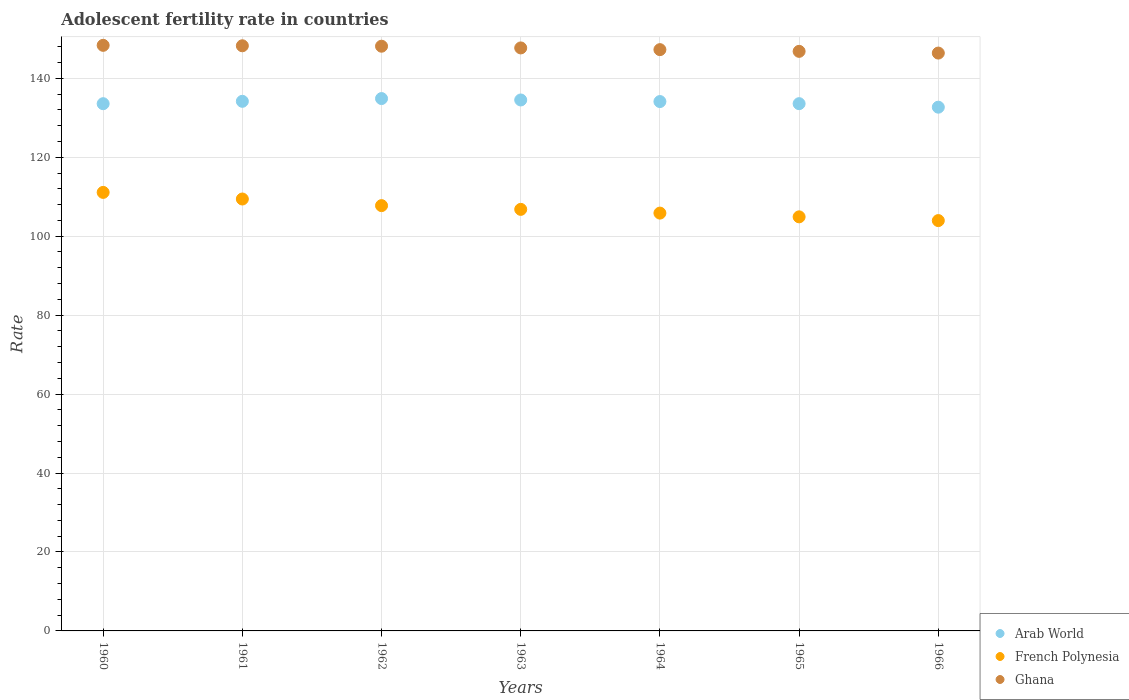What is the adolescent fertility rate in Arab World in 1962?
Provide a short and direct response. 134.86. Across all years, what is the maximum adolescent fertility rate in Ghana?
Provide a short and direct response. 148.34. Across all years, what is the minimum adolescent fertility rate in Arab World?
Give a very brief answer. 132.68. In which year was the adolescent fertility rate in French Polynesia maximum?
Your answer should be compact. 1960. In which year was the adolescent fertility rate in Arab World minimum?
Keep it short and to the point. 1966. What is the total adolescent fertility rate in Ghana in the graph?
Your answer should be very brief. 1032.86. What is the difference between the adolescent fertility rate in Arab World in 1960 and that in 1966?
Provide a short and direct response. 0.88. What is the difference between the adolescent fertility rate in Arab World in 1960 and the adolescent fertility rate in French Polynesia in 1965?
Provide a succinct answer. 28.66. What is the average adolescent fertility rate in French Polynesia per year?
Ensure brevity in your answer.  107.1. In the year 1964, what is the difference between the adolescent fertility rate in Ghana and adolescent fertility rate in Arab World?
Make the answer very short. 13.15. In how many years, is the adolescent fertility rate in Ghana greater than 100?
Ensure brevity in your answer.  7. What is the ratio of the adolescent fertility rate in Arab World in 1961 to that in 1966?
Provide a short and direct response. 1.01. Is the difference between the adolescent fertility rate in Ghana in 1963 and 1966 greater than the difference between the adolescent fertility rate in Arab World in 1963 and 1966?
Offer a terse response. No. What is the difference between the highest and the second highest adolescent fertility rate in Arab World?
Keep it short and to the point. 0.36. What is the difference between the highest and the lowest adolescent fertility rate in Arab World?
Provide a short and direct response. 2.18. In how many years, is the adolescent fertility rate in Arab World greater than the average adolescent fertility rate in Arab World taken over all years?
Provide a short and direct response. 4. Is the sum of the adolescent fertility rate in Arab World in 1960 and 1963 greater than the maximum adolescent fertility rate in French Polynesia across all years?
Your answer should be compact. Yes. Is it the case that in every year, the sum of the adolescent fertility rate in Ghana and adolescent fertility rate in French Polynesia  is greater than the adolescent fertility rate in Arab World?
Keep it short and to the point. Yes. Does the adolescent fertility rate in Ghana monotonically increase over the years?
Your answer should be very brief. No. Where does the legend appear in the graph?
Your answer should be compact. Bottom right. How many legend labels are there?
Provide a succinct answer. 3. What is the title of the graph?
Ensure brevity in your answer.  Adolescent fertility rate in countries. What is the label or title of the Y-axis?
Give a very brief answer. Rate. What is the Rate of Arab World in 1960?
Ensure brevity in your answer.  133.56. What is the Rate of French Polynesia in 1960?
Keep it short and to the point. 111.09. What is the Rate of Ghana in 1960?
Offer a terse response. 148.34. What is the Rate of Arab World in 1961?
Give a very brief answer. 134.16. What is the Rate of French Polynesia in 1961?
Ensure brevity in your answer.  109.41. What is the Rate in Ghana in 1961?
Provide a succinct answer. 148.23. What is the Rate in Arab World in 1962?
Provide a short and direct response. 134.86. What is the Rate of French Polynesia in 1962?
Offer a terse response. 107.74. What is the Rate in Ghana in 1962?
Offer a terse response. 148.12. What is the Rate of Arab World in 1963?
Ensure brevity in your answer.  134.5. What is the Rate in French Polynesia in 1963?
Provide a succinct answer. 106.79. What is the Rate in Ghana in 1963?
Your response must be concise. 147.69. What is the Rate in Arab World in 1964?
Make the answer very short. 134.1. What is the Rate in French Polynesia in 1964?
Offer a very short reply. 105.84. What is the Rate in Ghana in 1964?
Your response must be concise. 147.26. What is the Rate in Arab World in 1965?
Offer a very short reply. 133.57. What is the Rate of French Polynesia in 1965?
Offer a terse response. 104.9. What is the Rate of Ghana in 1965?
Offer a terse response. 146.82. What is the Rate in Arab World in 1966?
Give a very brief answer. 132.68. What is the Rate in French Polynesia in 1966?
Provide a succinct answer. 103.95. What is the Rate of Ghana in 1966?
Ensure brevity in your answer.  146.39. Across all years, what is the maximum Rate in Arab World?
Your answer should be very brief. 134.86. Across all years, what is the maximum Rate of French Polynesia?
Keep it short and to the point. 111.09. Across all years, what is the maximum Rate in Ghana?
Keep it short and to the point. 148.34. Across all years, what is the minimum Rate of Arab World?
Your answer should be compact. 132.68. Across all years, what is the minimum Rate of French Polynesia?
Provide a short and direct response. 103.95. Across all years, what is the minimum Rate of Ghana?
Your answer should be very brief. 146.39. What is the total Rate of Arab World in the graph?
Make the answer very short. 937.44. What is the total Rate in French Polynesia in the graph?
Provide a succinct answer. 749.73. What is the total Rate in Ghana in the graph?
Your answer should be very brief. 1032.86. What is the difference between the Rate of Arab World in 1960 and that in 1961?
Keep it short and to the point. -0.6. What is the difference between the Rate of French Polynesia in 1960 and that in 1961?
Ensure brevity in your answer.  1.68. What is the difference between the Rate in Ghana in 1960 and that in 1961?
Your answer should be compact. 0.11. What is the difference between the Rate of Arab World in 1960 and that in 1962?
Ensure brevity in your answer.  -1.3. What is the difference between the Rate of French Polynesia in 1960 and that in 1962?
Give a very brief answer. 3.35. What is the difference between the Rate of Ghana in 1960 and that in 1962?
Offer a very short reply. 0.22. What is the difference between the Rate in Arab World in 1960 and that in 1963?
Your answer should be compact. -0.94. What is the difference between the Rate of French Polynesia in 1960 and that in 1963?
Provide a short and direct response. 4.3. What is the difference between the Rate of Ghana in 1960 and that in 1963?
Give a very brief answer. 0.66. What is the difference between the Rate of Arab World in 1960 and that in 1964?
Provide a succinct answer. -0.54. What is the difference between the Rate of French Polynesia in 1960 and that in 1964?
Keep it short and to the point. 5.25. What is the difference between the Rate in Ghana in 1960 and that in 1964?
Your answer should be very brief. 1.09. What is the difference between the Rate in Arab World in 1960 and that in 1965?
Your response must be concise. -0.01. What is the difference between the Rate in French Polynesia in 1960 and that in 1965?
Your response must be concise. 6.19. What is the difference between the Rate of Ghana in 1960 and that in 1965?
Your response must be concise. 1.52. What is the difference between the Rate in Arab World in 1960 and that in 1966?
Provide a succinct answer. 0.88. What is the difference between the Rate in French Polynesia in 1960 and that in 1966?
Ensure brevity in your answer.  7.14. What is the difference between the Rate in Ghana in 1960 and that in 1966?
Give a very brief answer. 1.96. What is the difference between the Rate in Arab World in 1961 and that in 1962?
Offer a terse response. -0.7. What is the difference between the Rate in French Polynesia in 1961 and that in 1962?
Offer a terse response. 1.68. What is the difference between the Rate of Ghana in 1961 and that in 1962?
Offer a very short reply. 0.11. What is the difference between the Rate in Arab World in 1961 and that in 1963?
Your answer should be very brief. -0.34. What is the difference between the Rate in French Polynesia in 1961 and that in 1963?
Your answer should be compact. 2.62. What is the difference between the Rate of Ghana in 1961 and that in 1963?
Your answer should be very brief. 0.54. What is the difference between the Rate of Arab World in 1961 and that in 1964?
Ensure brevity in your answer.  0.06. What is the difference between the Rate of French Polynesia in 1961 and that in 1964?
Keep it short and to the point. 3.57. What is the difference between the Rate of Ghana in 1961 and that in 1964?
Keep it short and to the point. 0.98. What is the difference between the Rate in Arab World in 1961 and that in 1965?
Provide a succinct answer. 0.6. What is the difference between the Rate of French Polynesia in 1961 and that in 1965?
Provide a succinct answer. 4.52. What is the difference between the Rate in Ghana in 1961 and that in 1965?
Your response must be concise. 1.41. What is the difference between the Rate in Arab World in 1961 and that in 1966?
Provide a succinct answer. 1.49. What is the difference between the Rate of French Polynesia in 1961 and that in 1966?
Keep it short and to the point. 5.47. What is the difference between the Rate of Ghana in 1961 and that in 1966?
Provide a short and direct response. 1.85. What is the difference between the Rate of Arab World in 1962 and that in 1963?
Offer a very short reply. 0.36. What is the difference between the Rate of French Polynesia in 1962 and that in 1963?
Offer a very short reply. 0.95. What is the difference between the Rate in Ghana in 1962 and that in 1963?
Your response must be concise. 0.43. What is the difference between the Rate in Arab World in 1962 and that in 1964?
Give a very brief answer. 0.76. What is the difference between the Rate of French Polynesia in 1962 and that in 1964?
Give a very brief answer. 1.89. What is the difference between the Rate of Ghana in 1962 and that in 1964?
Your answer should be compact. 0.87. What is the difference between the Rate in Arab World in 1962 and that in 1965?
Ensure brevity in your answer.  1.29. What is the difference between the Rate in French Polynesia in 1962 and that in 1965?
Ensure brevity in your answer.  2.84. What is the difference between the Rate of Ghana in 1962 and that in 1965?
Provide a succinct answer. 1.3. What is the difference between the Rate in Arab World in 1962 and that in 1966?
Ensure brevity in your answer.  2.18. What is the difference between the Rate in French Polynesia in 1962 and that in 1966?
Your answer should be compact. 3.79. What is the difference between the Rate in Ghana in 1962 and that in 1966?
Provide a succinct answer. 1.74. What is the difference between the Rate of Arab World in 1963 and that in 1964?
Keep it short and to the point. 0.4. What is the difference between the Rate of Ghana in 1963 and that in 1964?
Provide a short and direct response. 0.43. What is the difference between the Rate in Arab World in 1963 and that in 1965?
Ensure brevity in your answer.  0.94. What is the difference between the Rate of French Polynesia in 1963 and that in 1965?
Provide a short and direct response. 1.89. What is the difference between the Rate of Ghana in 1963 and that in 1965?
Your response must be concise. 0.87. What is the difference between the Rate in Arab World in 1963 and that in 1966?
Your response must be concise. 1.83. What is the difference between the Rate in French Polynesia in 1963 and that in 1966?
Give a very brief answer. 2.84. What is the difference between the Rate of Ghana in 1963 and that in 1966?
Offer a very short reply. 1.3. What is the difference between the Rate of Arab World in 1964 and that in 1965?
Keep it short and to the point. 0.54. What is the difference between the Rate in French Polynesia in 1964 and that in 1965?
Your answer should be very brief. 0.95. What is the difference between the Rate in Ghana in 1964 and that in 1965?
Your answer should be very brief. 0.43. What is the difference between the Rate in Arab World in 1964 and that in 1966?
Offer a terse response. 1.43. What is the difference between the Rate in French Polynesia in 1964 and that in 1966?
Your answer should be very brief. 1.89. What is the difference between the Rate in Ghana in 1964 and that in 1966?
Provide a short and direct response. 0.87. What is the difference between the Rate in Arab World in 1965 and that in 1966?
Offer a terse response. 0.89. What is the difference between the Rate of French Polynesia in 1965 and that in 1966?
Offer a terse response. 0.95. What is the difference between the Rate of Ghana in 1965 and that in 1966?
Offer a terse response. 0.43. What is the difference between the Rate of Arab World in 1960 and the Rate of French Polynesia in 1961?
Your answer should be very brief. 24.15. What is the difference between the Rate of Arab World in 1960 and the Rate of Ghana in 1961?
Your answer should be compact. -14.67. What is the difference between the Rate of French Polynesia in 1960 and the Rate of Ghana in 1961?
Provide a short and direct response. -37.14. What is the difference between the Rate of Arab World in 1960 and the Rate of French Polynesia in 1962?
Your response must be concise. 25.82. What is the difference between the Rate of Arab World in 1960 and the Rate of Ghana in 1962?
Your answer should be compact. -14.56. What is the difference between the Rate of French Polynesia in 1960 and the Rate of Ghana in 1962?
Ensure brevity in your answer.  -37.03. What is the difference between the Rate of Arab World in 1960 and the Rate of French Polynesia in 1963?
Make the answer very short. 26.77. What is the difference between the Rate in Arab World in 1960 and the Rate in Ghana in 1963?
Your answer should be compact. -14.13. What is the difference between the Rate in French Polynesia in 1960 and the Rate in Ghana in 1963?
Your answer should be compact. -36.6. What is the difference between the Rate of Arab World in 1960 and the Rate of French Polynesia in 1964?
Your answer should be compact. 27.72. What is the difference between the Rate in Arab World in 1960 and the Rate in Ghana in 1964?
Give a very brief answer. -13.69. What is the difference between the Rate of French Polynesia in 1960 and the Rate of Ghana in 1964?
Your answer should be very brief. -36.16. What is the difference between the Rate in Arab World in 1960 and the Rate in French Polynesia in 1965?
Offer a very short reply. 28.66. What is the difference between the Rate in Arab World in 1960 and the Rate in Ghana in 1965?
Your response must be concise. -13.26. What is the difference between the Rate in French Polynesia in 1960 and the Rate in Ghana in 1965?
Provide a short and direct response. -35.73. What is the difference between the Rate of Arab World in 1960 and the Rate of French Polynesia in 1966?
Make the answer very short. 29.61. What is the difference between the Rate of Arab World in 1960 and the Rate of Ghana in 1966?
Keep it short and to the point. -12.83. What is the difference between the Rate of French Polynesia in 1960 and the Rate of Ghana in 1966?
Provide a short and direct response. -35.3. What is the difference between the Rate of Arab World in 1961 and the Rate of French Polynesia in 1962?
Offer a very short reply. 26.43. What is the difference between the Rate in Arab World in 1961 and the Rate in Ghana in 1962?
Offer a terse response. -13.96. What is the difference between the Rate in French Polynesia in 1961 and the Rate in Ghana in 1962?
Give a very brief answer. -38.71. What is the difference between the Rate in Arab World in 1961 and the Rate in French Polynesia in 1963?
Keep it short and to the point. 27.37. What is the difference between the Rate in Arab World in 1961 and the Rate in Ghana in 1963?
Your answer should be compact. -13.53. What is the difference between the Rate in French Polynesia in 1961 and the Rate in Ghana in 1963?
Offer a terse response. -38.27. What is the difference between the Rate of Arab World in 1961 and the Rate of French Polynesia in 1964?
Offer a very short reply. 28.32. What is the difference between the Rate of Arab World in 1961 and the Rate of Ghana in 1964?
Offer a terse response. -13.09. What is the difference between the Rate in French Polynesia in 1961 and the Rate in Ghana in 1964?
Ensure brevity in your answer.  -37.84. What is the difference between the Rate in Arab World in 1961 and the Rate in French Polynesia in 1965?
Provide a succinct answer. 29.27. What is the difference between the Rate of Arab World in 1961 and the Rate of Ghana in 1965?
Provide a succinct answer. -12.66. What is the difference between the Rate of French Polynesia in 1961 and the Rate of Ghana in 1965?
Your answer should be compact. -37.41. What is the difference between the Rate in Arab World in 1961 and the Rate in French Polynesia in 1966?
Keep it short and to the point. 30.21. What is the difference between the Rate in Arab World in 1961 and the Rate in Ghana in 1966?
Provide a succinct answer. -12.22. What is the difference between the Rate in French Polynesia in 1961 and the Rate in Ghana in 1966?
Offer a very short reply. -36.97. What is the difference between the Rate of Arab World in 1962 and the Rate of French Polynesia in 1963?
Make the answer very short. 28.07. What is the difference between the Rate of Arab World in 1962 and the Rate of Ghana in 1963?
Offer a very short reply. -12.83. What is the difference between the Rate in French Polynesia in 1962 and the Rate in Ghana in 1963?
Your response must be concise. -39.95. What is the difference between the Rate of Arab World in 1962 and the Rate of French Polynesia in 1964?
Offer a very short reply. 29.02. What is the difference between the Rate of Arab World in 1962 and the Rate of Ghana in 1964?
Your answer should be very brief. -12.39. What is the difference between the Rate in French Polynesia in 1962 and the Rate in Ghana in 1964?
Give a very brief answer. -39.52. What is the difference between the Rate of Arab World in 1962 and the Rate of French Polynesia in 1965?
Offer a very short reply. 29.96. What is the difference between the Rate of Arab World in 1962 and the Rate of Ghana in 1965?
Make the answer very short. -11.96. What is the difference between the Rate of French Polynesia in 1962 and the Rate of Ghana in 1965?
Provide a succinct answer. -39.08. What is the difference between the Rate of Arab World in 1962 and the Rate of French Polynesia in 1966?
Provide a succinct answer. 30.91. What is the difference between the Rate in Arab World in 1962 and the Rate in Ghana in 1966?
Offer a terse response. -11.53. What is the difference between the Rate in French Polynesia in 1962 and the Rate in Ghana in 1966?
Your answer should be compact. -38.65. What is the difference between the Rate of Arab World in 1963 and the Rate of French Polynesia in 1964?
Provide a short and direct response. 28.66. What is the difference between the Rate of Arab World in 1963 and the Rate of Ghana in 1964?
Offer a terse response. -12.75. What is the difference between the Rate of French Polynesia in 1963 and the Rate of Ghana in 1964?
Offer a very short reply. -40.46. What is the difference between the Rate in Arab World in 1963 and the Rate in French Polynesia in 1965?
Keep it short and to the point. 29.61. What is the difference between the Rate of Arab World in 1963 and the Rate of Ghana in 1965?
Your answer should be compact. -12.32. What is the difference between the Rate of French Polynesia in 1963 and the Rate of Ghana in 1965?
Your answer should be very brief. -40.03. What is the difference between the Rate in Arab World in 1963 and the Rate in French Polynesia in 1966?
Provide a short and direct response. 30.56. What is the difference between the Rate in Arab World in 1963 and the Rate in Ghana in 1966?
Give a very brief answer. -11.88. What is the difference between the Rate in French Polynesia in 1963 and the Rate in Ghana in 1966?
Keep it short and to the point. -39.59. What is the difference between the Rate of Arab World in 1964 and the Rate of French Polynesia in 1965?
Offer a terse response. 29.21. What is the difference between the Rate in Arab World in 1964 and the Rate in Ghana in 1965?
Give a very brief answer. -12.72. What is the difference between the Rate of French Polynesia in 1964 and the Rate of Ghana in 1965?
Offer a very short reply. -40.98. What is the difference between the Rate in Arab World in 1964 and the Rate in French Polynesia in 1966?
Give a very brief answer. 30.15. What is the difference between the Rate in Arab World in 1964 and the Rate in Ghana in 1966?
Offer a terse response. -12.28. What is the difference between the Rate in French Polynesia in 1964 and the Rate in Ghana in 1966?
Ensure brevity in your answer.  -40.54. What is the difference between the Rate in Arab World in 1965 and the Rate in French Polynesia in 1966?
Your answer should be compact. 29.62. What is the difference between the Rate of Arab World in 1965 and the Rate of Ghana in 1966?
Your answer should be very brief. -12.82. What is the difference between the Rate in French Polynesia in 1965 and the Rate in Ghana in 1966?
Make the answer very short. -41.49. What is the average Rate of Arab World per year?
Keep it short and to the point. 133.92. What is the average Rate in French Polynesia per year?
Your response must be concise. 107.1. What is the average Rate of Ghana per year?
Ensure brevity in your answer.  147.55. In the year 1960, what is the difference between the Rate of Arab World and Rate of French Polynesia?
Your answer should be very brief. 22.47. In the year 1960, what is the difference between the Rate in Arab World and Rate in Ghana?
Ensure brevity in your answer.  -14.78. In the year 1960, what is the difference between the Rate of French Polynesia and Rate of Ghana?
Ensure brevity in your answer.  -37.25. In the year 1961, what is the difference between the Rate of Arab World and Rate of French Polynesia?
Your answer should be compact. 24.75. In the year 1961, what is the difference between the Rate in Arab World and Rate in Ghana?
Make the answer very short. -14.07. In the year 1961, what is the difference between the Rate of French Polynesia and Rate of Ghana?
Make the answer very short. -38.82. In the year 1962, what is the difference between the Rate of Arab World and Rate of French Polynesia?
Ensure brevity in your answer.  27.12. In the year 1962, what is the difference between the Rate of Arab World and Rate of Ghana?
Offer a terse response. -13.26. In the year 1962, what is the difference between the Rate in French Polynesia and Rate in Ghana?
Offer a very short reply. -40.38. In the year 1963, what is the difference between the Rate in Arab World and Rate in French Polynesia?
Provide a succinct answer. 27.71. In the year 1963, what is the difference between the Rate in Arab World and Rate in Ghana?
Offer a terse response. -13.18. In the year 1963, what is the difference between the Rate of French Polynesia and Rate of Ghana?
Make the answer very short. -40.9. In the year 1964, what is the difference between the Rate in Arab World and Rate in French Polynesia?
Offer a terse response. 28.26. In the year 1964, what is the difference between the Rate of Arab World and Rate of Ghana?
Offer a terse response. -13.15. In the year 1964, what is the difference between the Rate in French Polynesia and Rate in Ghana?
Make the answer very short. -41.41. In the year 1965, what is the difference between the Rate of Arab World and Rate of French Polynesia?
Keep it short and to the point. 28.67. In the year 1965, what is the difference between the Rate in Arab World and Rate in Ghana?
Keep it short and to the point. -13.25. In the year 1965, what is the difference between the Rate of French Polynesia and Rate of Ghana?
Provide a short and direct response. -41.92. In the year 1966, what is the difference between the Rate in Arab World and Rate in French Polynesia?
Provide a short and direct response. 28.73. In the year 1966, what is the difference between the Rate in Arab World and Rate in Ghana?
Keep it short and to the point. -13.71. In the year 1966, what is the difference between the Rate of French Polynesia and Rate of Ghana?
Provide a short and direct response. -42.44. What is the ratio of the Rate in French Polynesia in 1960 to that in 1961?
Offer a terse response. 1.02. What is the ratio of the Rate of Ghana in 1960 to that in 1961?
Your response must be concise. 1. What is the ratio of the Rate in Arab World in 1960 to that in 1962?
Your response must be concise. 0.99. What is the ratio of the Rate in French Polynesia in 1960 to that in 1962?
Give a very brief answer. 1.03. What is the ratio of the Rate of French Polynesia in 1960 to that in 1963?
Give a very brief answer. 1.04. What is the ratio of the Rate of Arab World in 1960 to that in 1964?
Make the answer very short. 1. What is the ratio of the Rate of French Polynesia in 1960 to that in 1964?
Your answer should be compact. 1.05. What is the ratio of the Rate of Ghana in 1960 to that in 1964?
Offer a very short reply. 1.01. What is the ratio of the Rate of Arab World in 1960 to that in 1965?
Give a very brief answer. 1. What is the ratio of the Rate of French Polynesia in 1960 to that in 1965?
Ensure brevity in your answer.  1.06. What is the ratio of the Rate of Ghana in 1960 to that in 1965?
Offer a very short reply. 1.01. What is the ratio of the Rate in French Polynesia in 1960 to that in 1966?
Offer a very short reply. 1.07. What is the ratio of the Rate of Ghana in 1960 to that in 1966?
Your answer should be compact. 1.01. What is the ratio of the Rate of Arab World in 1961 to that in 1962?
Provide a succinct answer. 0.99. What is the ratio of the Rate in French Polynesia in 1961 to that in 1962?
Keep it short and to the point. 1.02. What is the ratio of the Rate in Ghana in 1961 to that in 1962?
Provide a short and direct response. 1. What is the ratio of the Rate in French Polynesia in 1961 to that in 1963?
Provide a short and direct response. 1.02. What is the ratio of the Rate of Ghana in 1961 to that in 1963?
Your answer should be compact. 1. What is the ratio of the Rate in Arab World in 1961 to that in 1964?
Offer a very short reply. 1. What is the ratio of the Rate of French Polynesia in 1961 to that in 1964?
Keep it short and to the point. 1.03. What is the ratio of the Rate in Ghana in 1961 to that in 1964?
Offer a very short reply. 1.01. What is the ratio of the Rate in French Polynesia in 1961 to that in 1965?
Your answer should be compact. 1.04. What is the ratio of the Rate in Ghana in 1961 to that in 1965?
Keep it short and to the point. 1.01. What is the ratio of the Rate in Arab World in 1961 to that in 1966?
Your response must be concise. 1.01. What is the ratio of the Rate of French Polynesia in 1961 to that in 1966?
Provide a succinct answer. 1.05. What is the ratio of the Rate of Ghana in 1961 to that in 1966?
Make the answer very short. 1.01. What is the ratio of the Rate in French Polynesia in 1962 to that in 1963?
Your response must be concise. 1.01. What is the ratio of the Rate in Ghana in 1962 to that in 1963?
Your response must be concise. 1. What is the ratio of the Rate in Arab World in 1962 to that in 1964?
Your answer should be compact. 1.01. What is the ratio of the Rate in French Polynesia in 1962 to that in 1964?
Offer a very short reply. 1.02. What is the ratio of the Rate of Ghana in 1962 to that in 1964?
Give a very brief answer. 1.01. What is the ratio of the Rate of Arab World in 1962 to that in 1965?
Your response must be concise. 1.01. What is the ratio of the Rate of French Polynesia in 1962 to that in 1965?
Give a very brief answer. 1.03. What is the ratio of the Rate in Ghana in 1962 to that in 1965?
Provide a succinct answer. 1.01. What is the ratio of the Rate of Arab World in 1962 to that in 1966?
Offer a very short reply. 1.02. What is the ratio of the Rate of French Polynesia in 1962 to that in 1966?
Give a very brief answer. 1.04. What is the ratio of the Rate of Ghana in 1962 to that in 1966?
Your response must be concise. 1.01. What is the ratio of the Rate in Arab World in 1963 to that in 1964?
Provide a succinct answer. 1. What is the ratio of the Rate of French Polynesia in 1963 to that in 1965?
Provide a short and direct response. 1.02. What is the ratio of the Rate in Ghana in 1963 to that in 1965?
Provide a short and direct response. 1.01. What is the ratio of the Rate of Arab World in 1963 to that in 1966?
Your answer should be compact. 1.01. What is the ratio of the Rate in French Polynesia in 1963 to that in 1966?
Make the answer very short. 1.03. What is the ratio of the Rate in Ghana in 1963 to that in 1966?
Offer a very short reply. 1.01. What is the ratio of the Rate of Arab World in 1964 to that in 1965?
Give a very brief answer. 1. What is the ratio of the Rate of French Polynesia in 1964 to that in 1965?
Your answer should be compact. 1.01. What is the ratio of the Rate of Arab World in 1964 to that in 1966?
Ensure brevity in your answer.  1.01. What is the ratio of the Rate of French Polynesia in 1964 to that in 1966?
Your answer should be compact. 1.02. What is the ratio of the Rate in Ghana in 1964 to that in 1966?
Your response must be concise. 1.01. What is the ratio of the Rate of Arab World in 1965 to that in 1966?
Your answer should be compact. 1.01. What is the ratio of the Rate in French Polynesia in 1965 to that in 1966?
Your answer should be compact. 1.01. What is the ratio of the Rate in Ghana in 1965 to that in 1966?
Provide a succinct answer. 1. What is the difference between the highest and the second highest Rate in Arab World?
Offer a terse response. 0.36. What is the difference between the highest and the second highest Rate in French Polynesia?
Offer a very short reply. 1.68. What is the difference between the highest and the second highest Rate of Ghana?
Ensure brevity in your answer.  0.11. What is the difference between the highest and the lowest Rate of Arab World?
Give a very brief answer. 2.18. What is the difference between the highest and the lowest Rate of French Polynesia?
Keep it short and to the point. 7.14. What is the difference between the highest and the lowest Rate in Ghana?
Provide a short and direct response. 1.96. 